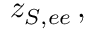Convert formula to latex. <formula><loc_0><loc_0><loc_500><loc_500>z _ { S , e e } \, ,</formula> 